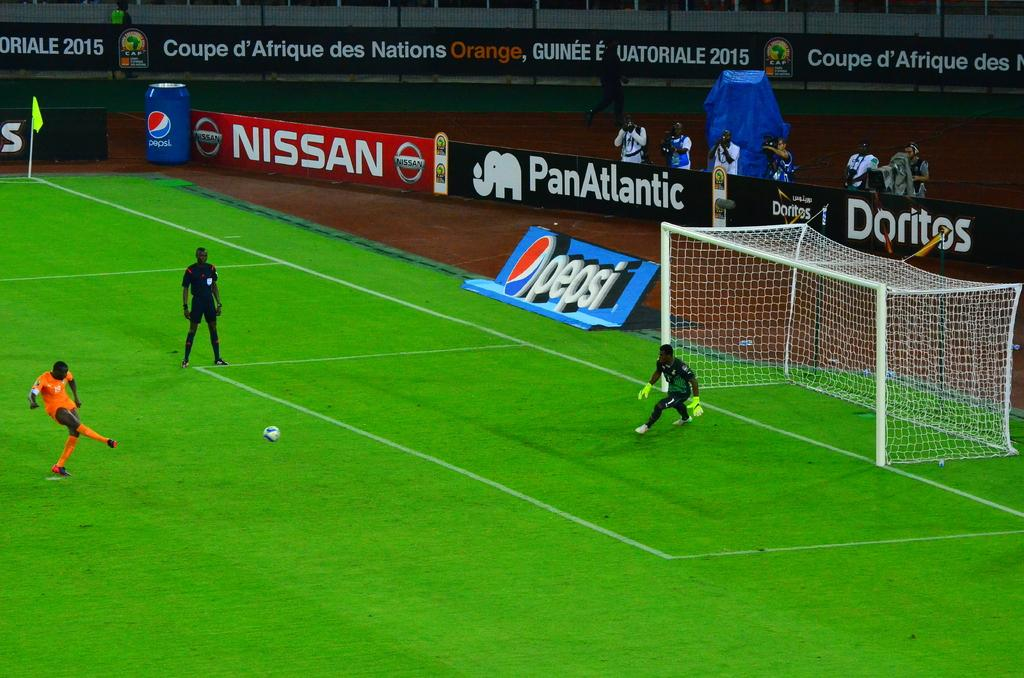Provide a one-sentence caption for the provided image. Players playing soccer on a field with an advertisement for doritos behind them. 